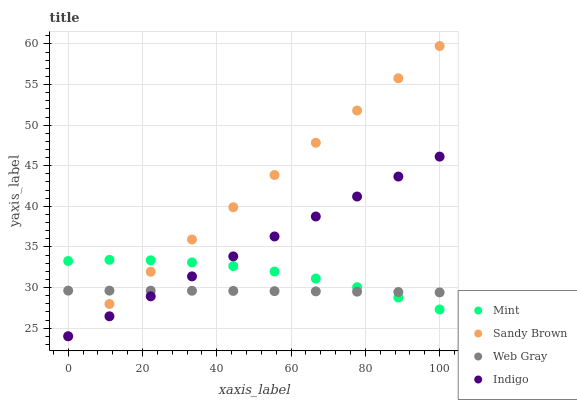Does Web Gray have the minimum area under the curve?
Answer yes or no. Yes. Does Sandy Brown have the maximum area under the curve?
Answer yes or no. Yes. Does Mint have the minimum area under the curve?
Answer yes or no. No. Does Mint have the maximum area under the curve?
Answer yes or no. No. Is Sandy Brown the smoothest?
Answer yes or no. Yes. Is Mint the roughest?
Answer yes or no. Yes. Is Web Gray the smoothest?
Answer yes or no. No. Is Web Gray the roughest?
Answer yes or no. No. Does Sandy Brown have the lowest value?
Answer yes or no. Yes. Does Mint have the lowest value?
Answer yes or no. No. Does Sandy Brown have the highest value?
Answer yes or no. Yes. Does Mint have the highest value?
Answer yes or no. No. Does Web Gray intersect Indigo?
Answer yes or no. Yes. Is Web Gray less than Indigo?
Answer yes or no. No. Is Web Gray greater than Indigo?
Answer yes or no. No. 